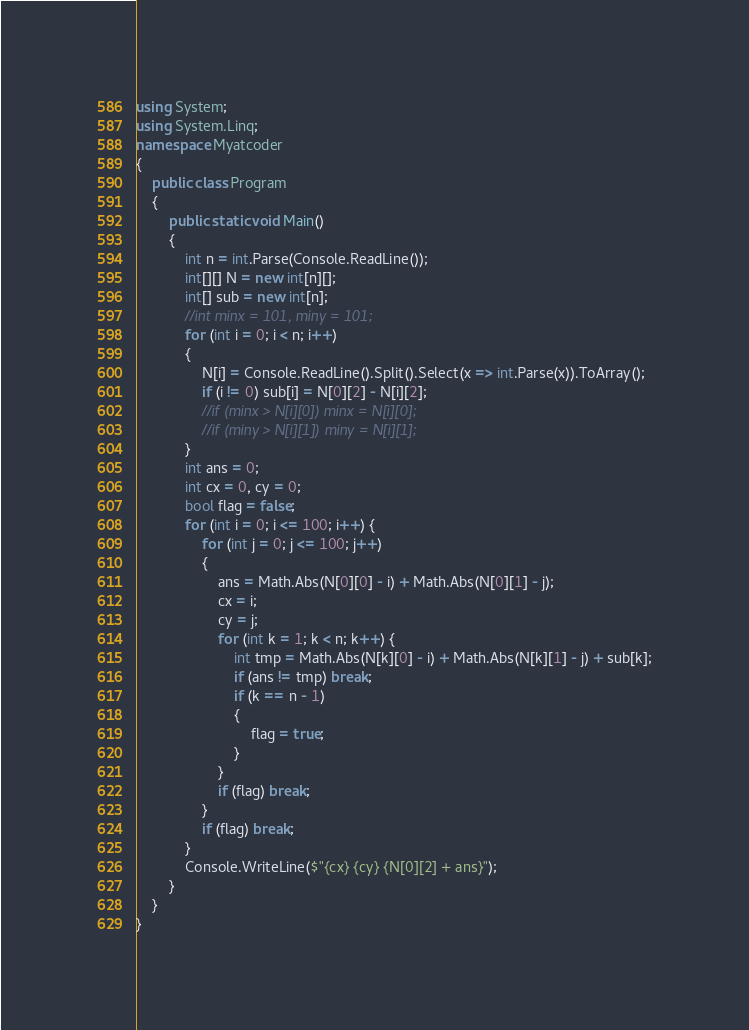Convert code to text. <code><loc_0><loc_0><loc_500><loc_500><_C#_>using System;
using System.Linq;
namespace Myatcoder
{
    public class Program
    {
        public static void Main()
        {
            int n = int.Parse(Console.ReadLine());
            int[][] N = new int[n][];
            int[] sub = new int[n];
            //int minx = 101, miny = 101;
            for (int i = 0; i < n; i++)
            {
                N[i] = Console.ReadLine().Split().Select(x => int.Parse(x)).ToArray();
                if (i != 0) sub[i] = N[0][2] - N[i][2];
                //if (minx > N[i][0]) minx = N[i][0];
                //if (miny > N[i][1]) miny = N[i][1];
            }
            int ans = 0;
            int cx = 0, cy = 0;
            bool flag = false;
            for (int i = 0; i <= 100; i++) {
                for (int j = 0; j <= 100; j++)
                {
                    ans = Math.Abs(N[0][0] - i) + Math.Abs(N[0][1] - j); 
                    cx = i;
                    cy = j;
                    for (int k = 1; k < n; k++) {
                        int tmp = Math.Abs(N[k][0] - i) + Math.Abs(N[k][1] - j) + sub[k];
                        if (ans != tmp) break;
                        if (k == n - 1)
                        {
                            flag = true;
                        }
                    }
                    if (flag) break;
                }
                if (flag) break;
            }
            Console.WriteLine($"{cx} {cy} {N[0][2] + ans}");
        }
    }
}</code> 